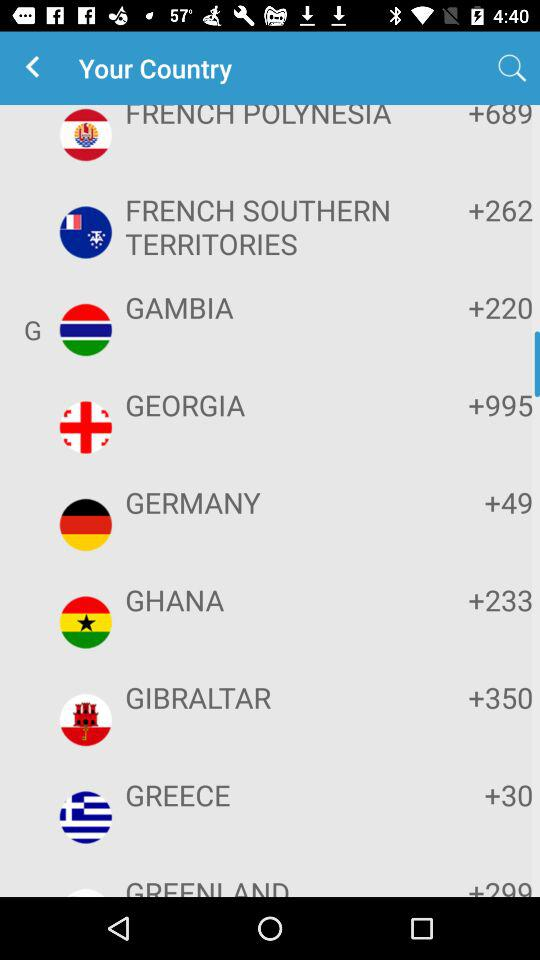Which country is selected?
When the provided information is insufficient, respond with <no answer>. <no answer> 